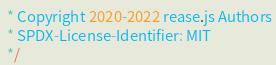Convert code to text. <code><loc_0><loc_0><loc_500><loc_500><_JavaScript_> * Copyright 2020-2022 rease.js Authors
 * SPDX-License-Identifier: MIT
 */</code> 